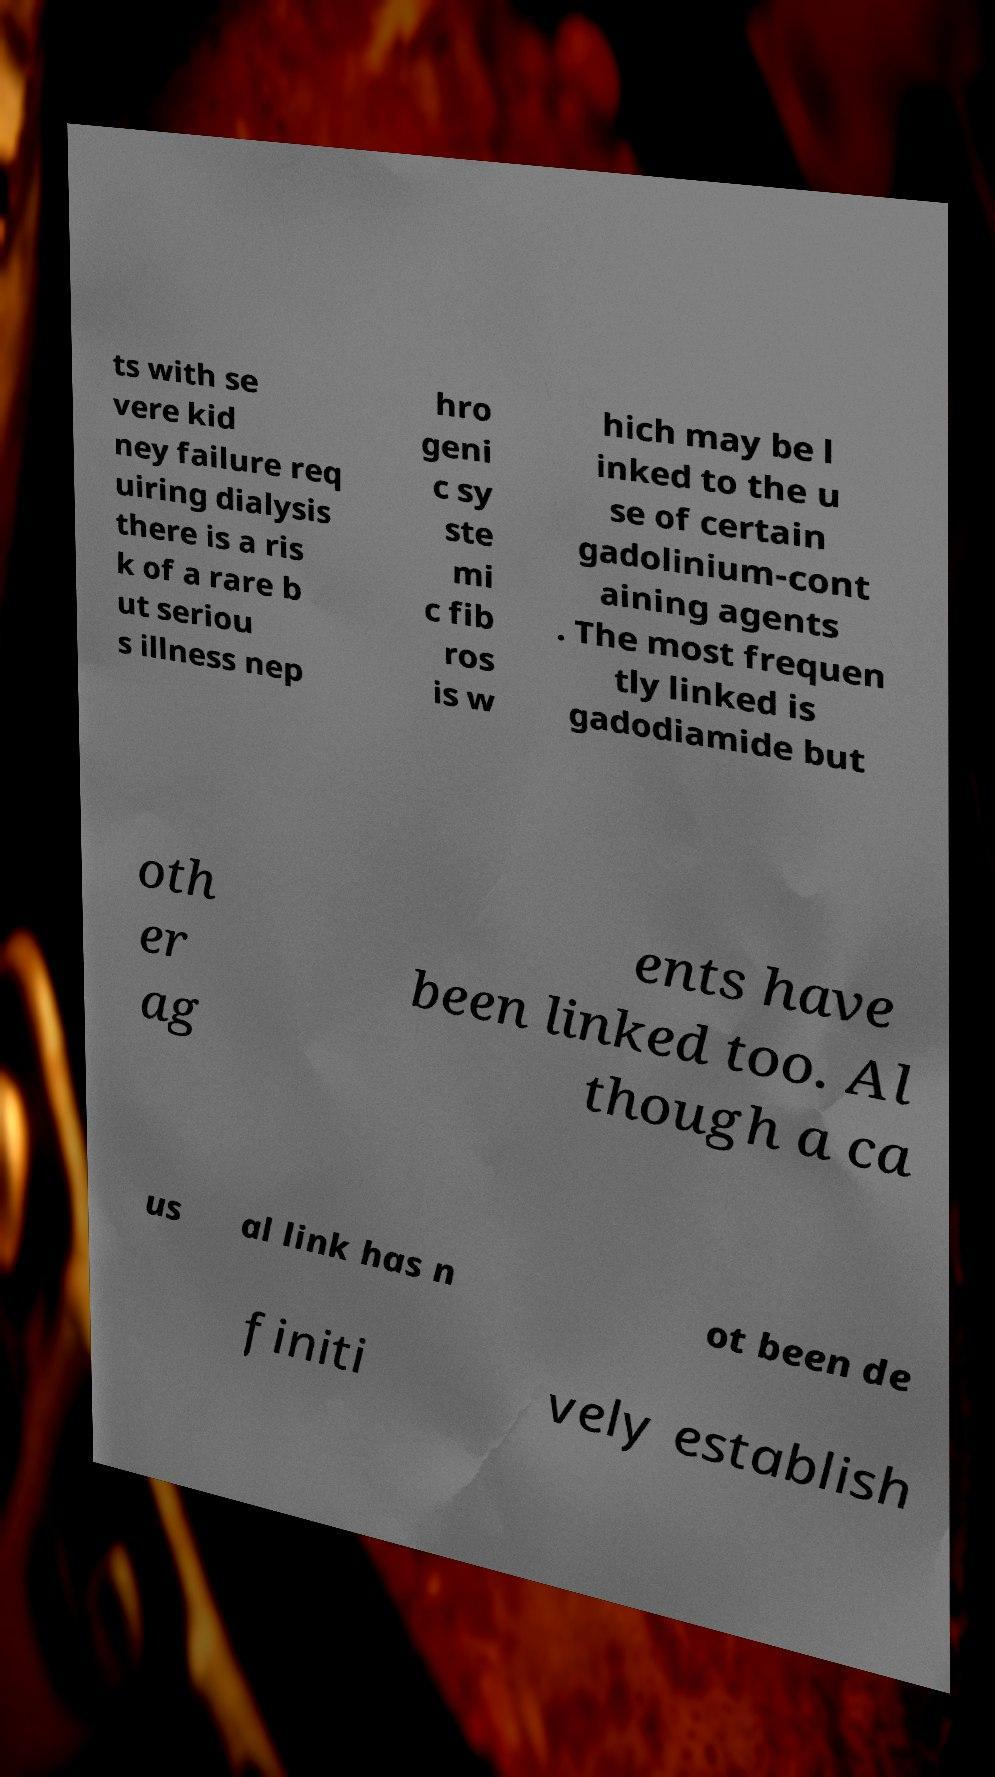There's text embedded in this image that I need extracted. Can you transcribe it verbatim? ts with se vere kid ney failure req uiring dialysis there is a ris k of a rare b ut seriou s illness nep hro geni c sy ste mi c fib ros is w hich may be l inked to the u se of certain gadolinium-cont aining agents . The most frequen tly linked is gadodiamide but oth er ag ents have been linked too. Al though a ca us al link has n ot been de finiti vely establish 